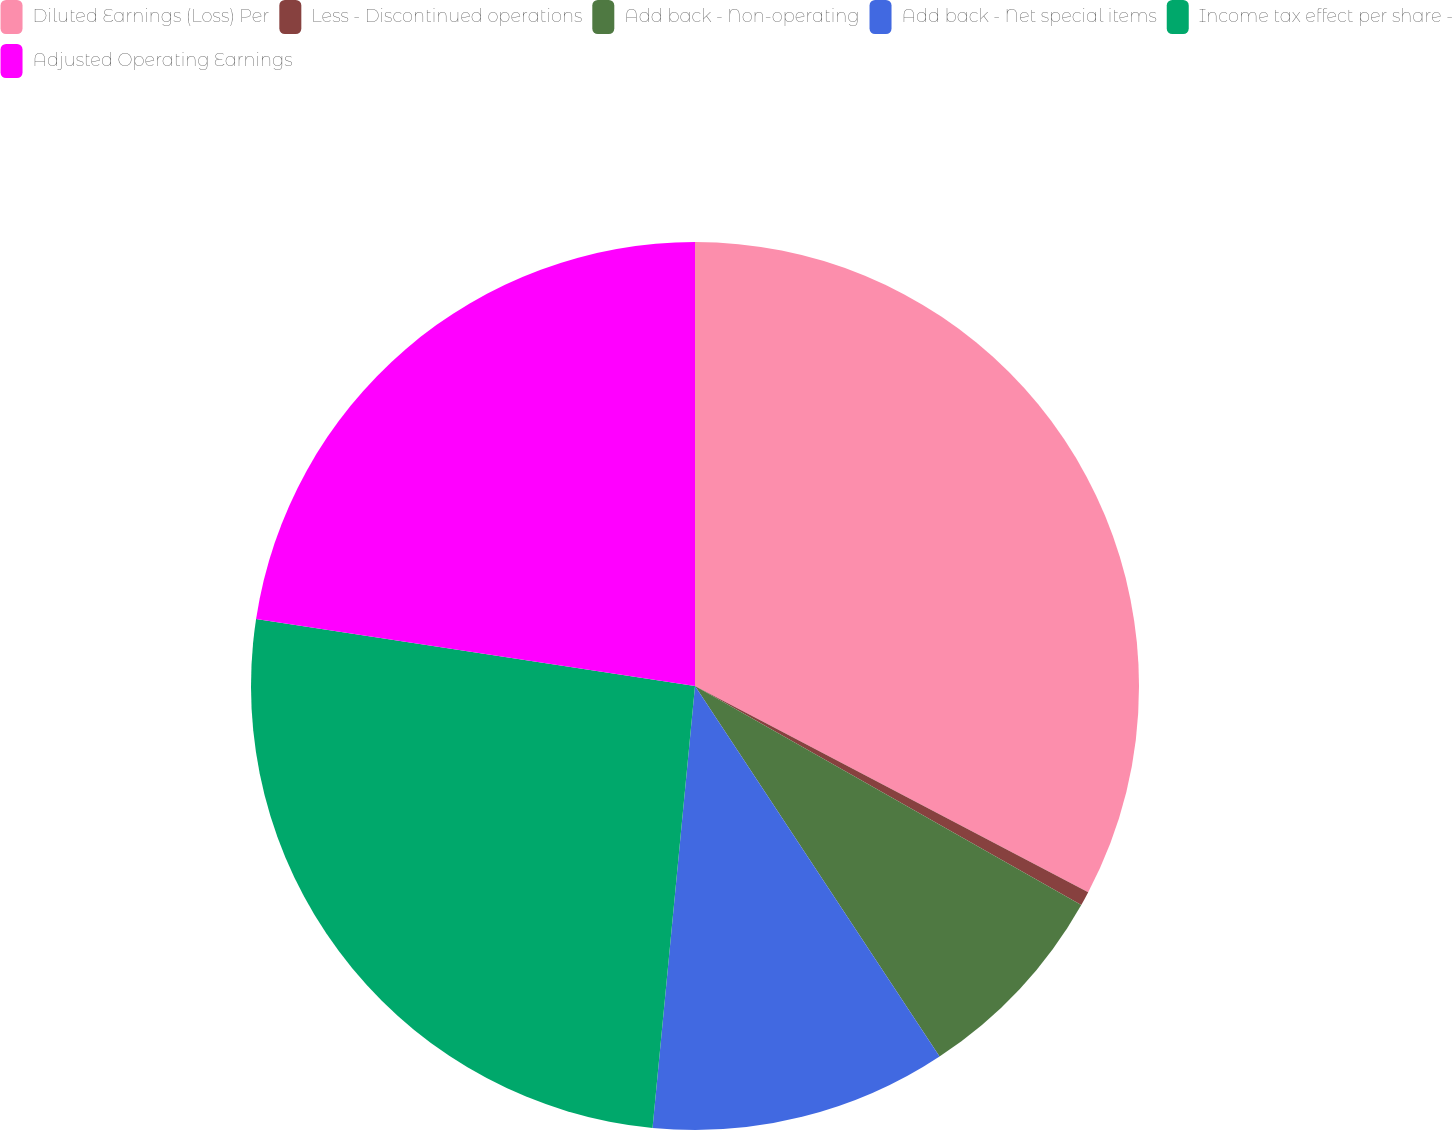<chart> <loc_0><loc_0><loc_500><loc_500><pie_chart><fcel>Diluted Earnings (Loss) Per<fcel>Less - Discontinued operations<fcel>Add back - Non-operating<fcel>Add back - Net special items<fcel>Income tax effect per share -<fcel>Adjusted Operating Earnings<nl><fcel>32.69%<fcel>0.52%<fcel>7.51%<fcel>10.81%<fcel>25.89%<fcel>22.59%<nl></chart> 